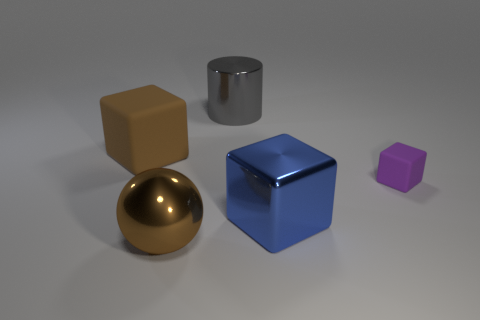How many things are matte blocks that are left of the big blue metal object or rubber cubes to the right of the metallic cylinder?
Your answer should be compact. 2. Is there anything else that is the same shape as the brown metal object?
Make the answer very short. No. What number of matte objects are there?
Keep it short and to the point. 2. Are there any brown cubes that have the same size as the gray metal cylinder?
Your answer should be compact. Yes. Does the blue thing have the same material as the big cube behind the small purple rubber object?
Provide a succinct answer. No. What is the material of the big cube in front of the big brown matte thing?
Your answer should be very brief. Metal. The brown block has what size?
Keep it short and to the point. Large. There is a block on the left side of the large blue block; is it the same size as the metallic thing behind the small thing?
Offer a terse response. Yes. What size is the brown object that is the same shape as the purple object?
Provide a succinct answer. Large. There is a blue metallic block; does it have the same size as the rubber block that is right of the large ball?
Provide a short and direct response. No. 